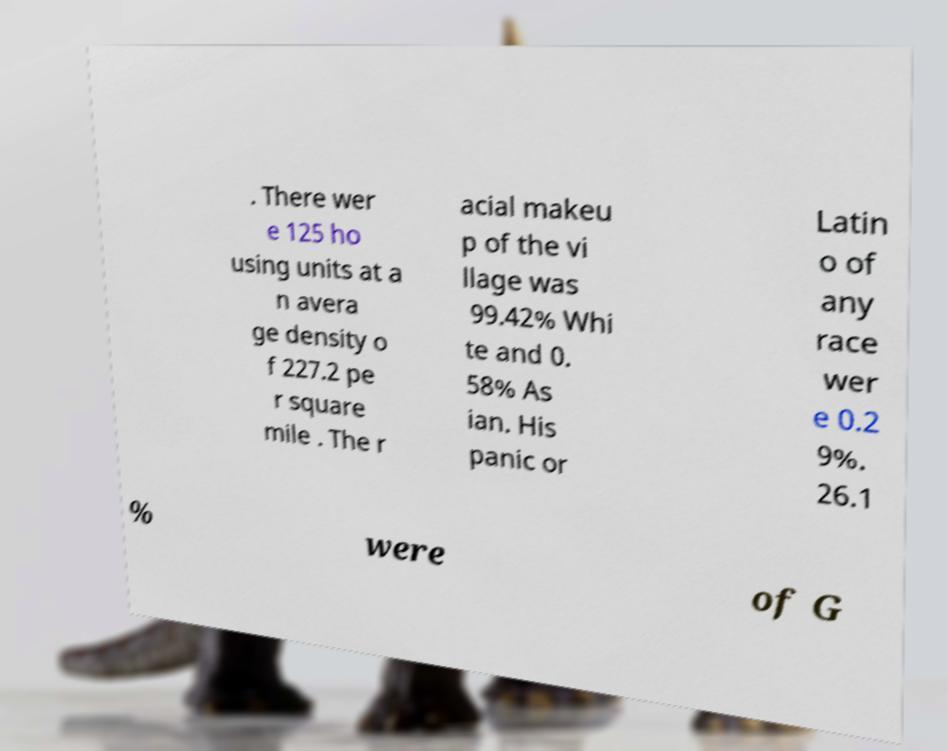I need the written content from this picture converted into text. Can you do that? . There wer e 125 ho using units at a n avera ge density o f 227.2 pe r square mile . The r acial makeu p of the vi llage was 99.42% Whi te and 0. 58% As ian. His panic or Latin o of any race wer e 0.2 9%. 26.1 % were of G 